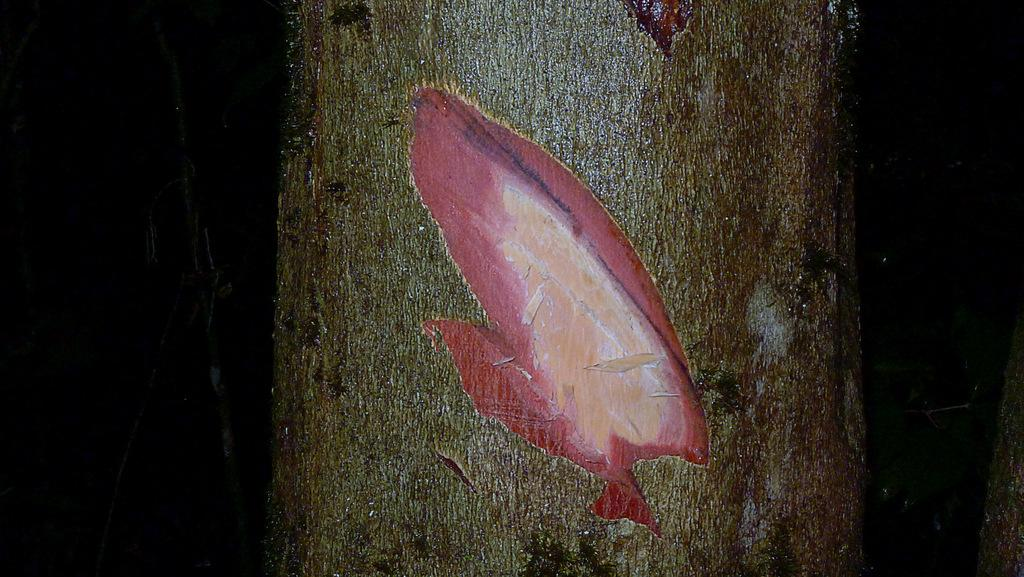What is the main subject of the image? The main subject of the image is a stem. Can you describe the stem in the image? Unfortunately, without more information, it is difficult to describe the stem in detail. How many pages are visible in the image? There are no pages present in the image, as it only features a stem. How many visitors can be seen interacting with the stem in the image? There are no visitors present in the image, as it only features a stem. 